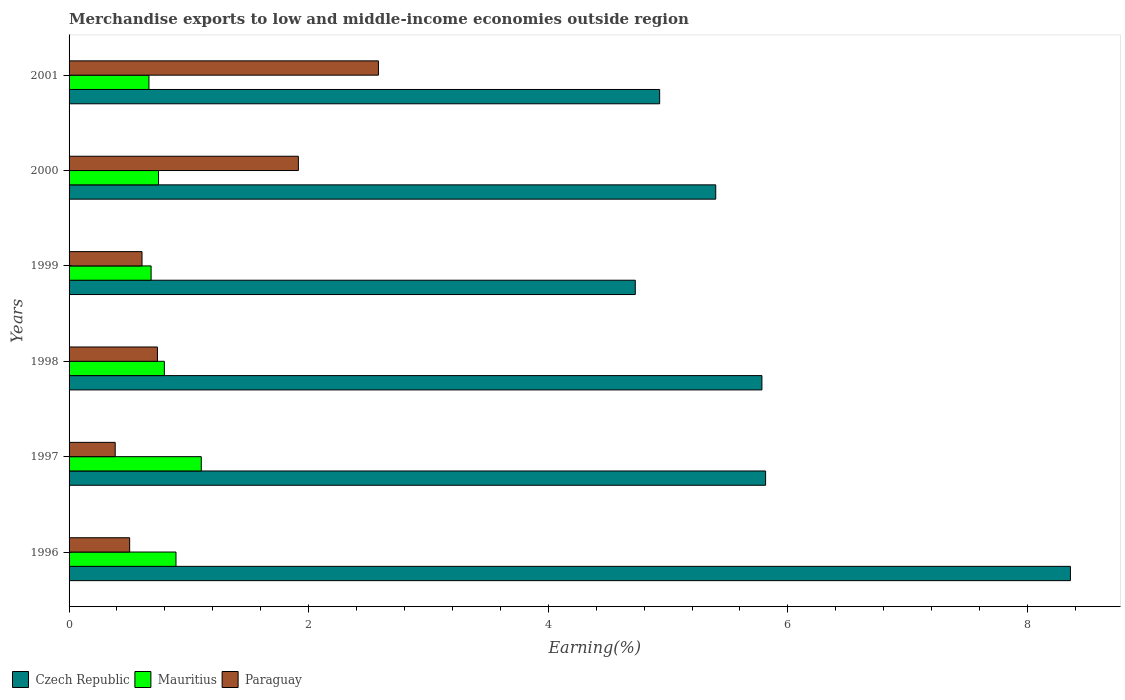How many bars are there on the 5th tick from the bottom?
Offer a terse response. 3. What is the label of the 1st group of bars from the top?
Provide a succinct answer. 2001. What is the percentage of amount earned from merchandise exports in Paraguay in 2001?
Your answer should be compact. 2.58. Across all years, what is the maximum percentage of amount earned from merchandise exports in Czech Republic?
Your response must be concise. 8.36. Across all years, what is the minimum percentage of amount earned from merchandise exports in Paraguay?
Your answer should be compact. 0.39. What is the total percentage of amount earned from merchandise exports in Paraguay in the graph?
Provide a succinct answer. 6.73. What is the difference between the percentage of amount earned from merchandise exports in Czech Republic in 1997 and that in 1999?
Provide a succinct answer. 1.09. What is the difference between the percentage of amount earned from merchandise exports in Mauritius in 2000 and the percentage of amount earned from merchandise exports in Paraguay in 1998?
Give a very brief answer. 0.01. What is the average percentage of amount earned from merchandise exports in Paraguay per year?
Offer a terse response. 1.12. In the year 1999, what is the difference between the percentage of amount earned from merchandise exports in Mauritius and percentage of amount earned from merchandise exports in Paraguay?
Provide a short and direct response. 0.08. What is the ratio of the percentage of amount earned from merchandise exports in Paraguay in 1996 to that in 1997?
Provide a short and direct response. 1.31. Is the percentage of amount earned from merchandise exports in Czech Republic in 1996 less than that in 2000?
Keep it short and to the point. No. What is the difference between the highest and the second highest percentage of amount earned from merchandise exports in Mauritius?
Ensure brevity in your answer.  0.21. What is the difference between the highest and the lowest percentage of amount earned from merchandise exports in Paraguay?
Make the answer very short. 2.2. In how many years, is the percentage of amount earned from merchandise exports in Paraguay greater than the average percentage of amount earned from merchandise exports in Paraguay taken over all years?
Make the answer very short. 2. Is the sum of the percentage of amount earned from merchandise exports in Mauritius in 1999 and 2001 greater than the maximum percentage of amount earned from merchandise exports in Czech Republic across all years?
Give a very brief answer. No. What does the 3rd bar from the top in 1997 represents?
Ensure brevity in your answer.  Czech Republic. What does the 2nd bar from the bottom in 2001 represents?
Offer a very short reply. Mauritius. Is it the case that in every year, the sum of the percentage of amount earned from merchandise exports in Mauritius and percentage of amount earned from merchandise exports in Czech Republic is greater than the percentage of amount earned from merchandise exports in Paraguay?
Provide a succinct answer. Yes. How many bars are there?
Your answer should be compact. 18. Are all the bars in the graph horizontal?
Keep it short and to the point. Yes. How many years are there in the graph?
Give a very brief answer. 6. What is the difference between two consecutive major ticks on the X-axis?
Provide a succinct answer. 2. Are the values on the major ticks of X-axis written in scientific E-notation?
Offer a very short reply. No. Does the graph contain grids?
Offer a terse response. No. Where does the legend appear in the graph?
Your answer should be very brief. Bottom left. How many legend labels are there?
Offer a terse response. 3. How are the legend labels stacked?
Make the answer very short. Horizontal. What is the title of the graph?
Your answer should be compact. Merchandise exports to low and middle-income economies outside region. What is the label or title of the X-axis?
Provide a succinct answer. Earning(%). What is the Earning(%) of Czech Republic in 1996?
Ensure brevity in your answer.  8.36. What is the Earning(%) in Mauritius in 1996?
Your answer should be very brief. 0.89. What is the Earning(%) in Paraguay in 1996?
Keep it short and to the point. 0.51. What is the Earning(%) of Czech Republic in 1997?
Keep it short and to the point. 5.81. What is the Earning(%) of Mauritius in 1997?
Provide a succinct answer. 1.1. What is the Earning(%) in Paraguay in 1997?
Keep it short and to the point. 0.39. What is the Earning(%) of Czech Republic in 1998?
Offer a very short reply. 5.78. What is the Earning(%) in Mauritius in 1998?
Provide a succinct answer. 0.8. What is the Earning(%) of Paraguay in 1998?
Your answer should be very brief. 0.74. What is the Earning(%) of Czech Republic in 1999?
Make the answer very short. 4.73. What is the Earning(%) of Mauritius in 1999?
Provide a succinct answer. 0.68. What is the Earning(%) of Paraguay in 1999?
Provide a short and direct response. 0.61. What is the Earning(%) of Czech Republic in 2000?
Your response must be concise. 5.4. What is the Earning(%) of Mauritius in 2000?
Offer a very short reply. 0.75. What is the Earning(%) in Paraguay in 2000?
Offer a very short reply. 1.91. What is the Earning(%) of Czech Republic in 2001?
Your response must be concise. 4.93. What is the Earning(%) of Mauritius in 2001?
Your response must be concise. 0.67. What is the Earning(%) of Paraguay in 2001?
Offer a terse response. 2.58. Across all years, what is the maximum Earning(%) of Czech Republic?
Give a very brief answer. 8.36. Across all years, what is the maximum Earning(%) of Mauritius?
Keep it short and to the point. 1.1. Across all years, what is the maximum Earning(%) in Paraguay?
Offer a very short reply. 2.58. Across all years, what is the minimum Earning(%) of Czech Republic?
Offer a terse response. 4.73. Across all years, what is the minimum Earning(%) of Mauritius?
Make the answer very short. 0.67. Across all years, what is the minimum Earning(%) of Paraguay?
Provide a succinct answer. 0.39. What is the total Earning(%) of Czech Republic in the graph?
Keep it short and to the point. 35.01. What is the total Earning(%) of Mauritius in the graph?
Offer a terse response. 4.89. What is the total Earning(%) of Paraguay in the graph?
Keep it short and to the point. 6.73. What is the difference between the Earning(%) in Czech Republic in 1996 and that in 1997?
Your answer should be compact. 2.54. What is the difference between the Earning(%) of Mauritius in 1996 and that in 1997?
Provide a succinct answer. -0.21. What is the difference between the Earning(%) in Paraguay in 1996 and that in 1997?
Provide a succinct answer. 0.12. What is the difference between the Earning(%) in Czech Republic in 1996 and that in 1998?
Give a very brief answer. 2.58. What is the difference between the Earning(%) of Mauritius in 1996 and that in 1998?
Keep it short and to the point. 0.1. What is the difference between the Earning(%) of Paraguay in 1996 and that in 1998?
Offer a very short reply. -0.23. What is the difference between the Earning(%) of Czech Republic in 1996 and that in 1999?
Your response must be concise. 3.63. What is the difference between the Earning(%) in Mauritius in 1996 and that in 1999?
Offer a terse response. 0.21. What is the difference between the Earning(%) of Paraguay in 1996 and that in 1999?
Offer a terse response. -0.1. What is the difference between the Earning(%) in Czech Republic in 1996 and that in 2000?
Offer a very short reply. 2.96. What is the difference between the Earning(%) in Mauritius in 1996 and that in 2000?
Your answer should be compact. 0.15. What is the difference between the Earning(%) in Paraguay in 1996 and that in 2000?
Your response must be concise. -1.41. What is the difference between the Earning(%) in Czech Republic in 1996 and that in 2001?
Keep it short and to the point. 3.43. What is the difference between the Earning(%) in Mauritius in 1996 and that in 2001?
Give a very brief answer. 0.23. What is the difference between the Earning(%) of Paraguay in 1996 and that in 2001?
Provide a short and direct response. -2.08. What is the difference between the Earning(%) in Czech Republic in 1997 and that in 1998?
Ensure brevity in your answer.  0.03. What is the difference between the Earning(%) of Mauritius in 1997 and that in 1998?
Your answer should be compact. 0.31. What is the difference between the Earning(%) of Paraguay in 1997 and that in 1998?
Provide a succinct answer. -0.35. What is the difference between the Earning(%) of Czech Republic in 1997 and that in 1999?
Your answer should be very brief. 1.09. What is the difference between the Earning(%) in Mauritius in 1997 and that in 1999?
Your answer should be very brief. 0.42. What is the difference between the Earning(%) of Paraguay in 1997 and that in 1999?
Ensure brevity in your answer.  -0.22. What is the difference between the Earning(%) in Czech Republic in 1997 and that in 2000?
Provide a succinct answer. 0.42. What is the difference between the Earning(%) in Mauritius in 1997 and that in 2000?
Give a very brief answer. 0.36. What is the difference between the Earning(%) of Paraguay in 1997 and that in 2000?
Your answer should be compact. -1.53. What is the difference between the Earning(%) in Czech Republic in 1997 and that in 2001?
Give a very brief answer. 0.88. What is the difference between the Earning(%) in Mauritius in 1997 and that in 2001?
Offer a terse response. 0.44. What is the difference between the Earning(%) in Paraguay in 1997 and that in 2001?
Offer a terse response. -2.2. What is the difference between the Earning(%) of Czech Republic in 1998 and that in 1999?
Give a very brief answer. 1.06. What is the difference between the Earning(%) in Mauritius in 1998 and that in 1999?
Provide a succinct answer. 0.11. What is the difference between the Earning(%) in Paraguay in 1998 and that in 1999?
Ensure brevity in your answer.  0.13. What is the difference between the Earning(%) of Czech Republic in 1998 and that in 2000?
Your answer should be compact. 0.39. What is the difference between the Earning(%) of Mauritius in 1998 and that in 2000?
Give a very brief answer. 0.05. What is the difference between the Earning(%) in Paraguay in 1998 and that in 2000?
Make the answer very short. -1.18. What is the difference between the Earning(%) of Czech Republic in 1998 and that in 2001?
Your answer should be very brief. 0.85. What is the difference between the Earning(%) of Mauritius in 1998 and that in 2001?
Your response must be concise. 0.13. What is the difference between the Earning(%) in Paraguay in 1998 and that in 2001?
Your answer should be very brief. -1.84. What is the difference between the Earning(%) of Czech Republic in 1999 and that in 2000?
Offer a terse response. -0.67. What is the difference between the Earning(%) of Mauritius in 1999 and that in 2000?
Offer a terse response. -0.06. What is the difference between the Earning(%) of Paraguay in 1999 and that in 2000?
Give a very brief answer. -1.31. What is the difference between the Earning(%) in Czech Republic in 1999 and that in 2001?
Your response must be concise. -0.2. What is the difference between the Earning(%) of Mauritius in 1999 and that in 2001?
Give a very brief answer. 0.02. What is the difference between the Earning(%) of Paraguay in 1999 and that in 2001?
Make the answer very short. -1.97. What is the difference between the Earning(%) of Czech Republic in 2000 and that in 2001?
Provide a short and direct response. 0.47. What is the difference between the Earning(%) in Mauritius in 2000 and that in 2001?
Your response must be concise. 0.08. What is the difference between the Earning(%) in Paraguay in 2000 and that in 2001?
Your answer should be very brief. -0.67. What is the difference between the Earning(%) of Czech Republic in 1996 and the Earning(%) of Mauritius in 1997?
Offer a very short reply. 7.25. What is the difference between the Earning(%) of Czech Republic in 1996 and the Earning(%) of Paraguay in 1997?
Offer a terse response. 7.97. What is the difference between the Earning(%) in Mauritius in 1996 and the Earning(%) in Paraguay in 1997?
Provide a short and direct response. 0.51. What is the difference between the Earning(%) in Czech Republic in 1996 and the Earning(%) in Mauritius in 1998?
Offer a very short reply. 7.56. What is the difference between the Earning(%) of Czech Republic in 1996 and the Earning(%) of Paraguay in 1998?
Keep it short and to the point. 7.62. What is the difference between the Earning(%) of Mauritius in 1996 and the Earning(%) of Paraguay in 1998?
Give a very brief answer. 0.15. What is the difference between the Earning(%) in Czech Republic in 1996 and the Earning(%) in Mauritius in 1999?
Your answer should be compact. 7.67. What is the difference between the Earning(%) in Czech Republic in 1996 and the Earning(%) in Paraguay in 1999?
Provide a succinct answer. 7.75. What is the difference between the Earning(%) in Mauritius in 1996 and the Earning(%) in Paraguay in 1999?
Provide a succinct answer. 0.28. What is the difference between the Earning(%) of Czech Republic in 1996 and the Earning(%) of Mauritius in 2000?
Offer a very short reply. 7.61. What is the difference between the Earning(%) in Czech Republic in 1996 and the Earning(%) in Paraguay in 2000?
Your response must be concise. 6.44. What is the difference between the Earning(%) in Mauritius in 1996 and the Earning(%) in Paraguay in 2000?
Offer a terse response. -1.02. What is the difference between the Earning(%) in Czech Republic in 1996 and the Earning(%) in Mauritius in 2001?
Provide a succinct answer. 7.69. What is the difference between the Earning(%) of Czech Republic in 1996 and the Earning(%) of Paraguay in 2001?
Keep it short and to the point. 5.78. What is the difference between the Earning(%) in Mauritius in 1996 and the Earning(%) in Paraguay in 2001?
Offer a very short reply. -1.69. What is the difference between the Earning(%) in Czech Republic in 1997 and the Earning(%) in Mauritius in 1998?
Provide a succinct answer. 5.02. What is the difference between the Earning(%) of Czech Republic in 1997 and the Earning(%) of Paraguay in 1998?
Provide a short and direct response. 5.08. What is the difference between the Earning(%) in Mauritius in 1997 and the Earning(%) in Paraguay in 1998?
Offer a terse response. 0.37. What is the difference between the Earning(%) of Czech Republic in 1997 and the Earning(%) of Mauritius in 1999?
Give a very brief answer. 5.13. What is the difference between the Earning(%) of Czech Republic in 1997 and the Earning(%) of Paraguay in 1999?
Give a very brief answer. 5.21. What is the difference between the Earning(%) of Mauritius in 1997 and the Earning(%) of Paraguay in 1999?
Ensure brevity in your answer.  0.49. What is the difference between the Earning(%) in Czech Republic in 1997 and the Earning(%) in Mauritius in 2000?
Keep it short and to the point. 5.07. What is the difference between the Earning(%) in Czech Republic in 1997 and the Earning(%) in Paraguay in 2000?
Offer a very short reply. 3.9. What is the difference between the Earning(%) in Mauritius in 1997 and the Earning(%) in Paraguay in 2000?
Make the answer very short. -0.81. What is the difference between the Earning(%) of Czech Republic in 1997 and the Earning(%) of Mauritius in 2001?
Provide a short and direct response. 5.15. What is the difference between the Earning(%) of Czech Republic in 1997 and the Earning(%) of Paraguay in 2001?
Your answer should be very brief. 3.23. What is the difference between the Earning(%) of Mauritius in 1997 and the Earning(%) of Paraguay in 2001?
Your response must be concise. -1.48. What is the difference between the Earning(%) of Czech Republic in 1998 and the Earning(%) of Mauritius in 1999?
Your answer should be very brief. 5.1. What is the difference between the Earning(%) of Czech Republic in 1998 and the Earning(%) of Paraguay in 1999?
Provide a succinct answer. 5.17. What is the difference between the Earning(%) in Mauritius in 1998 and the Earning(%) in Paraguay in 1999?
Give a very brief answer. 0.19. What is the difference between the Earning(%) in Czech Republic in 1998 and the Earning(%) in Mauritius in 2000?
Offer a terse response. 5.04. What is the difference between the Earning(%) of Czech Republic in 1998 and the Earning(%) of Paraguay in 2000?
Your answer should be compact. 3.87. What is the difference between the Earning(%) of Mauritius in 1998 and the Earning(%) of Paraguay in 2000?
Give a very brief answer. -1.12. What is the difference between the Earning(%) in Czech Republic in 1998 and the Earning(%) in Mauritius in 2001?
Your answer should be compact. 5.12. What is the difference between the Earning(%) in Czech Republic in 1998 and the Earning(%) in Paraguay in 2001?
Provide a short and direct response. 3.2. What is the difference between the Earning(%) of Mauritius in 1998 and the Earning(%) of Paraguay in 2001?
Make the answer very short. -1.79. What is the difference between the Earning(%) of Czech Republic in 1999 and the Earning(%) of Mauritius in 2000?
Make the answer very short. 3.98. What is the difference between the Earning(%) of Czech Republic in 1999 and the Earning(%) of Paraguay in 2000?
Your answer should be compact. 2.81. What is the difference between the Earning(%) of Mauritius in 1999 and the Earning(%) of Paraguay in 2000?
Provide a short and direct response. -1.23. What is the difference between the Earning(%) of Czech Republic in 1999 and the Earning(%) of Mauritius in 2001?
Your answer should be very brief. 4.06. What is the difference between the Earning(%) of Czech Republic in 1999 and the Earning(%) of Paraguay in 2001?
Offer a terse response. 2.14. What is the difference between the Earning(%) in Mauritius in 1999 and the Earning(%) in Paraguay in 2001?
Offer a terse response. -1.9. What is the difference between the Earning(%) of Czech Republic in 2000 and the Earning(%) of Mauritius in 2001?
Ensure brevity in your answer.  4.73. What is the difference between the Earning(%) in Czech Republic in 2000 and the Earning(%) in Paraguay in 2001?
Offer a very short reply. 2.82. What is the difference between the Earning(%) in Mauritius in 2000 and the Earning(%) in Paraguay in 2001?
Ensure brevity in your answer.  -1.84. What is the average Earning(%) in Czech Republic per year?
Ensure brevity in your answer.  5.83. What is the average Earning(%) of Mauritius per year?
Your answer should be compact. 0.81. What is the average Earning(%) of Paraguay per year?
Make the answer very short. 1.12. In the year 1996, what is the difference between the Earning(%) in Czech Republic and Earning(%) in Mauritius?
Offer a terse response. 7.47. In the year 1996, what is the difference between the Earning(%) in Czech Republic and Earning(%) in Paraguay?
Provide a succinct answer. 7.85. In the year 1996, what is the difference between the Earning(%) of Mauritius and Earning(%) of Paraguay?
Ensure brevity in your answer.  0.39. In the year 1997, what is the difference between the Earning(%) in Czech Republic and Earning(%) in Mauritius?
Your response must be concise. 4.71. In the year 1997, what is the difference between the Earning(%) in Czech Republic and Earning(%) in Paraguay?
Your response must be concise. 5.43. In the year 1997, what is the difference between the Earning(%) in Mauritius and Earning(%) in Paraguay?
Provide a succinct answer. 0.72. In the year 1998, what is the difference between the Earning(%) of Czech Republic and Earning(%) of Mauritius?
Provide a short and direct response. 4.99. In the year 1998, what is the difference between the Earning(%) in Czech Republic and Earning(%) in Paraguay?
Provide a succinct answer. 5.05. In the year 1998, what is the difference between the Earning(%) of Mauritius and Earning(%) of Paraguay?
Provide a succinct answer. 0.06. In the year 1999, what is the difference between the Earning(%) of Czech Republic and Earning(%) of Mauritius?
Provide a succinct answer. 4.04. In the year 1999, what is the difference between the Earning(%) in Czech Republic and Earning(%) in Paraguay?
Make the answer very short. 4.12. In the year 1999, what is the difference between the Earning(%) in Mauritius and Earning(%) in Paraguay?
Your answer should be very brief. 0.08. In the year 2000, what is the difference between the Earning(%) of Czech Republic and Earning(%) of Mauritius?
Your answer should be very brief. 4.65. In the year 2000, what is the difference between the Earning(%) of Czech Republic and Earning(%) of Paraguay?
Provide a short and direct response. 3.48. In the year 2000, what is the difference between the Earning(%) of Mauritius and Earning(%) of Paraguay?
Give a very brief answer. -1.17. In the year 2001, what is the difference between the Earning(%) of Czech Republic and Earning(%) of Mauritius?
Your answer should be compact. 4.26. In the year 2001, what is the difference between the Earning(%) of Czech Republic and Earning(%) of Paraguay?
Your response must be concise. 2.35. In the year 2001, what is the difference between the Earning(%) of Mauritius and Earning(%) of Paraguay?
Provide a succinct answer. -1.92. What is the ratio of the Earning(%) in Czech Republic in 1996 to that in 1997?
Ensure brevity in your answer.  1.44. What is the ratio of the Earning(%) in Mauritius in 1996 to that in 1997?
Ensure brevity in your answer.  0.81. What is the ratio of the Earning(%) of Paraguay in 1996 to that in 1997?
Ensure brevity in your answer.  1.31. What is the ratio of the Earning(%) in Czech Republic in 1996 to that in 1998?
Give a very brief answer. 1.45. What is the ratio of the Earning(%) of Mauritius in 1996 to that in 1998?
Your answer should be very brief. 1.12. What is the ratio of the Earning(%) in Paraguay in 1996 to that in 1998?
Provide a succinct answer. 0.69. What is the ratio of the Earning(%) in Czech Republic in 1996 to that in 1999?
Provide a short and direct response. 1.77. What is the ratio of the Earning(%) of Mauritius in 1996 to that in 1999?
Offer a very short reply. 1.3. What is the ratio of the Earning(%) in Paraguay in 1996 to that in 1999?
Your answer should be compact. 0.83. What is the ratio of the Earning(%) in Czech Republic in 1996 to that in 2000?
Your answer should be very brief. 1.55. What is the ratio of the Earning(%) in Mauritius in 1996 to that in 2000?
Make the answer very short. 1.2. What is the ratio of the Earning(%) in Paraguay in 1996 to that in 2000?
Your answer should be very brief. 0.26. What is the ratio of the Earning(%) of Czech Republic in 1996 to that in 2001?
Your answer should be compact. 1.7. What is the ratio of the Earning(%) of Mauritius in 1996 to that in 2001?
Ensure brevity in your answer.  1.34. What is the ratio of the Earning(%) in Paraguay in 1996 to that in 2001?
Provide a succinct answer. 0.2. What is the ratio of the Earning(%) in Czech Republic in 1997 to that in 1998?
Provide a short and direct response. 1.01. What is the ratio of the Earning(%) of Mauritius in 1997 to that in 1998?
Your response must be concise. 1.39. What is the ratio of the Earning(%) in Paraguay in 1997 to that in 1998?
Your response must be concise. 0.52. What is the ratio of the Earning(%) of Czech Republic in 1997 to that in 1999?
Your response must be concise. 1.23. What is the ratio of the Earning(%) of Mauritius in 1997 to that in 1999?
Keep it short and to the point. 1.61. What is the ratio of the Earning(%) of Paraguay in 1997 to that in 1999?
Ensure brevity in your answer.  0.63. What is the ratio of the Earning(%) in Czech Republic in 1997 to that in 2000?
Keep it short and to the point. 1.08. What is the ratio of the Earning(%) in Mauritius in 1997 to that in 2000?
Offer a terse response. 1.48. What is the ratio of the Earning(%) in Paraguay in 1997 to that in 2000?
Offer a terse response. 0.2. What is the ratio of the Earning(%) of Czech Republic in 1997 to that in 2001?
Make the answer very short. 1.18. What is the ratio of the Earning(%) of Mauritius in 1997 to that in 2001?
Your response must be concise. 1.66. What is the ratio of the Earning(%) in Paraguay in 1997 to that in 2001?
Give a very brief answer. 0.15. What is the ratio of the Earning(%) of Czech Republic in 1998 to that in 1999?
Keep it short and to the point. 1.22. What is the ratio of the Earning(%) of Mauritius in 1998 to that in 1999?
Make the answer very short. 1.16. What is the ratio of the Earning(%) in Paraguay in 1998 to that in 1999?
Provide a succinct answer. 1.21. What is the ratio of the Earning(%) in Czech Republic in 1998 to that in 2000?
Offer a very short reply. 1.07. What is the ratio of the Earning(%) of Mauritius in 1998 to that in 2000?
Offer a very short reply. 1.07. What is the ratio of the Earning(%) in Paraguay in 1998 to that in 2000?
Make the answer very short. 0.39. What is the ratio of the Earning(%) in Czech Republic in 1998 to that in 2001?
Your answer should be very brief. 1.17. What is the ratio of the Earning(%) of Mauritius in 1998 to that in 2001?
Make the answer very short. 1.19. What is the ratio of the Earning(%) of Paraguay in 1998 to that in 2001?
Give a very brief answer. 0.29. What is the ratio of the Earning(%) in Czech Republic in 1999 to that in 2000?
Provide a short and direct response. 0.88. What is the ratio of the Earning(%) of Mauritius in 1999 to that in 2000?
Keep it short and to the point. 0.92. What is the ratio of the Earning(%) in Paraguay in 1999 to that in 2000?
Your response must be concise. 0.32. What is the ratio of the Earning(%) of Czech Republic in 1999 to that in 2001?
Your answer should be very brief. 0.96. What is the ratio of the Earning(%) in Mauritius in 1999 to that in 2001?
Your answer should be very brief. 1.03. What is the ratio of the Earning(%) of Paraguay in 1999 to that in 2001?
Keep it short and to the point. 0.24. What is the ratio of the Earning(%) in Czech Republic in 2000 to that in 2001?
Make the answer very short. 1.09. What is the ratio of the Earning(%) in Mauritius in 2000 to that in 2001?
Your response must be concise. 1.12. What is the ratio of the Earning(%) in Paraguay in 2000 to that in 2001?
Make the answer very short. 0.74. What is the difference between the highest and the second highest Earning(%) of Czech Republic?
Keep it short and to the point. 2.54. What is the difference between the highest and the second highest Earning(%) of Mauritius?
Your response must be concise. 0.21. What is the difference between the highest and the second highest Earning(%) of Paraguay?
Provide a succinct answer. 0.67. What is the difference between the highest and the lowest Earning(%) of Czech Republic?
Keep it short and to the point. 3.63. What is the difference between the highest and the lowest Earning(%) in Mauritius?
Ensure brevity in your answer.  0.44. What is the difference between the highest and the lowest Earning(%) of Paraguay?
Make the answer very short. 2.2. 